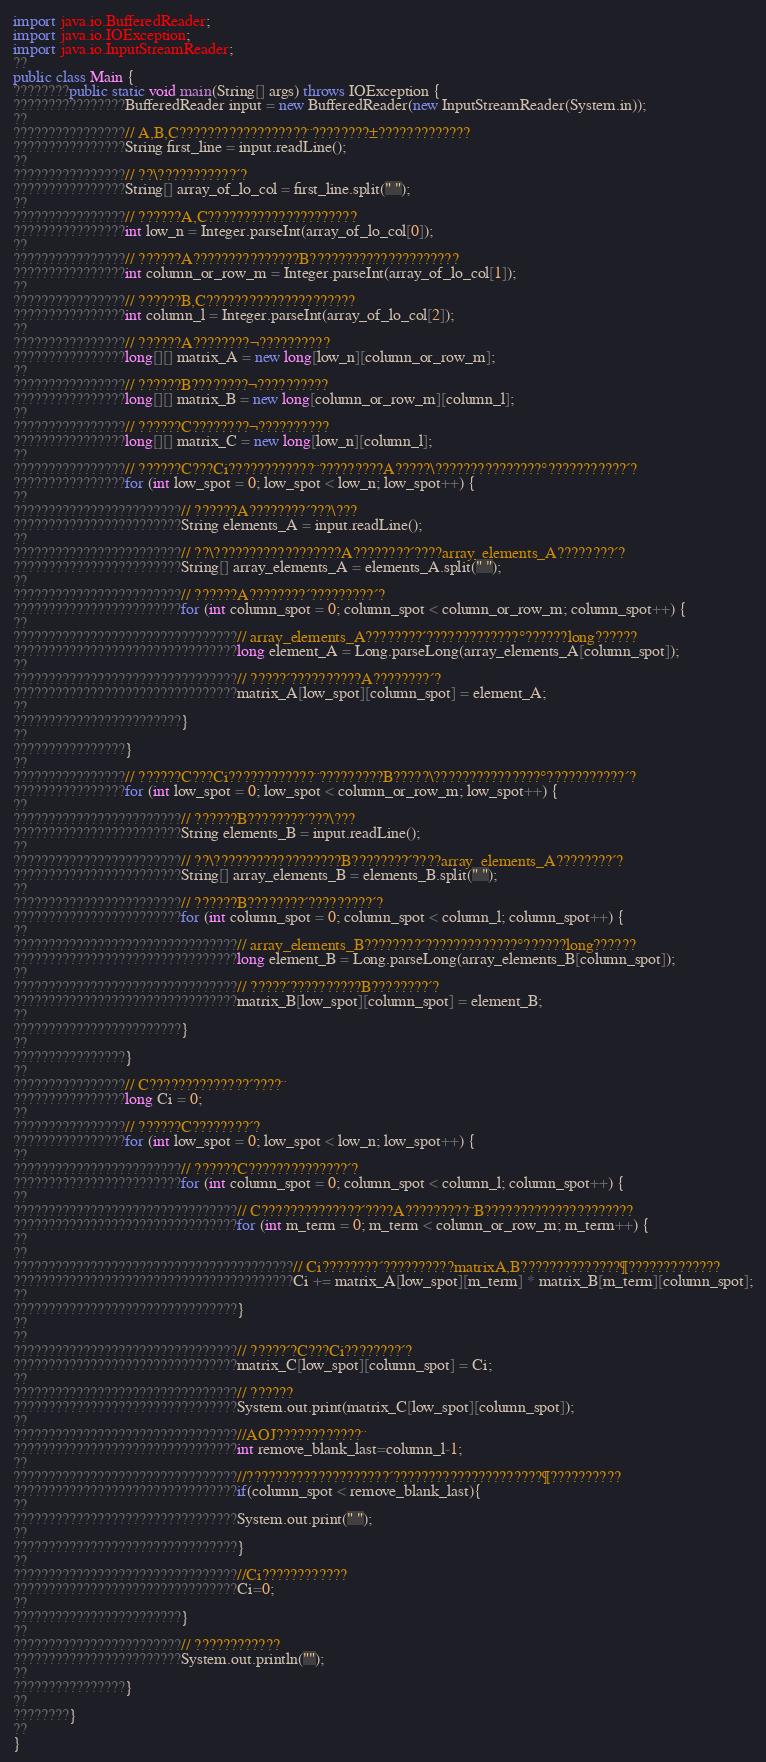<code> <loc_0><loc_0><loc_500><loc_500><_Java_>import java.io.BufferedReader;
import java.io.IOException;
import java.io.InputStreamReader;
??
public class Main {
????????public static void main(String[] args) throws IOException {
????????????????BufferedReader input = new BufferedReader(new InputStreamReader(System.in));
??
????????????????// A,B,C??????????????????¨????????±?????????????
????????????????String first_line = input.readLine();
??
????????????????// ??\???????????´?
????????????????String[] array_of_lo_col = first_line.split(" ");
??
????????????????// ??????A,C?????????????????????
????????????????int low_n = Integer.parseInt(array_of_lo_col[0]);
??
????????????????// ??????A???????????????B?????????????????????
????????????????int column_or_row_m = Integer.parseInt(array_of_lo_col[1]);
??
????????????????// ??????B,C?????????????????????
????????????????int column_l = Integer.parseInt(array_of_lo_col[2]);
??
????????????????// ??????A????????¬??????????
????????????????long[][] matrix_A = new long[low_n][column_or_row_m];
??
????????????????// ??????B????????¬??????????
????????????????long[][] matrix_B = new long[column_or_row_m][column_l];
??
????????????????// ??????C????????¬??????????
????????????????long[][] matrix_C = new long[low_n][column_l];
??
????????????????// ??????C???Ci????????????¨?????????A?????\???????????????°???????????´?
????????????????for (int low_spot = 0; low_spot < low_n; low_spot++) {
??
????????????????????????// ??????A????????´???\???
????????????????????????String elements_A = input.readLine();
??
????????????????????????// ??\??????????????????A????????´????array_elements_A????????´?
????????????????????????String[] array_elements_A = elements_A.split(" ");
??
????????????????????????// ??????A????????´?????????´?
????????????????????????for (int column_spot = 0; column_spot < column_or_row_m; column_spot++) {
??
????????????????????????????????// array_elements_A????????´?????????????°??????long??????
????????????????????????????????long element_A = Long.parseLong(array_elements_A[column_spot]);
??
????????????????????????????????// ?????´??????????A????????´?
????????????????????????????????matrix_A[low_spot][column_spot] = element_A;
??
????????????????????????}
??
????????????????}
??
????????????????// ??????C???Ci????????????¨?????????B?????\???????????????°???????????´?
????????????????for (int low_spot = 0; low_spot < column_or_row_m; low_spot++) {
??
????????????????????????// ??????B????????´???\???
????????????????????????String elements_B = input.readLine();
??
????????????????????????// ??\??????????????????B????????´????array_elements_A????????´?
????????????????????????String[] array_elements_B = elements_B.split(" ");
??
????????????????????????// ??????B????????´?????????´?
????????????????????????for (int column_spot = 0; column_spot < column_l; column_spot++) {
??
????????????????????????????????// array_elements_B????????´?????????????°??????long??????
????????????????????????????????long element_B = Long.parseLong(array_elements_B[column_spot]);
??
????????????????????????????????// ?????´??????????B????????´?
????????????????????????????????matrix_B[low_spot][column_spot] = element_B;
??
????????????????????????}
??
????????????????}
??
????????????????// C??????????????´????¨
????????????????long Ci = 0;
??
????????????????// ??????C????????´?
????????????????for (int low_spot = 0; low_spot < low_n; low_spot++) {
??
????????????????????????// ??????C??????????????´?
????????????????????????for (int column_spot = 0; column_spot < column_l; column_spot++) {
??
????????????????????????????????// C??????????????´????A?????????¨B?????????????????????
????????????????????????????????for (int m_term = 0; m_term < column_or_row_m; m_term++) {
??
??
????????????????????????????????????????// Ci????????´??????????matrixA,B??????????????¶?????????????
????????????????????????????????????????Ci += matrix_A[low_spot][m_term] * matrix_B[m_term][column_spot];
??
????????????????????????????????}
??
??
????????????????????????????????// ?????´?C???Ci????????´?
????????????????????????????????matrix_C[low_spot][column_spot] = Ci;
??
????????????????????????????????// ??????
????????????????????????????????System.out.print(matrix_C[low_spot][column_spot]);
??
????????????????????????????????//AOJ????????????¨
????????????????????????????????int remove_blank_last=column_l-1;
??
????????????????????????????????//????????????????????´?????????????????????¶??????????
????????????????????????????????if(column_spot < remove_blank_last){
??
????????????????????????????????System.out.print(" ");
??
????????????????????????????????}
??
????????????????????????????????//Ci????????????
????????????????????????????????Ci=0;
??
????????????????????????}
??
????????????????????????// ????????????
????????????????????????System.out.println("");
??
????????????????}
??
????????}
??
}</code> 